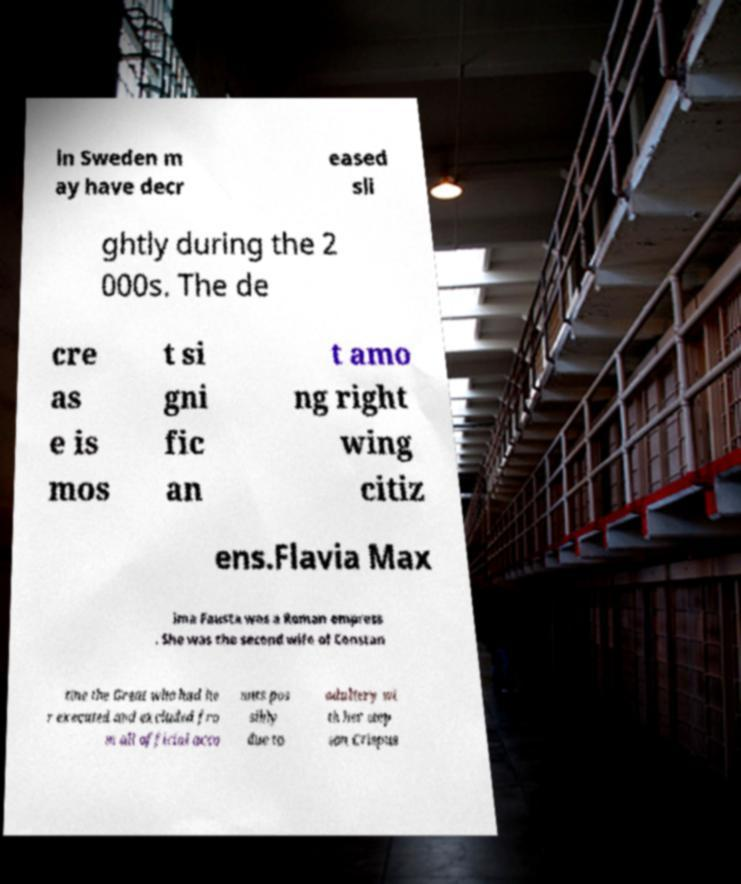Please read and relay the text visible in this image. What does it say? in Sweden m ay have decr eased sli ghtly during the 2 000s. The de cre as e is mos t si gni fic an t amo ng right wing citiz ens.Flavia Max ima Fausta was a Roman empress . She was the second wife of Constan tine the Great who had he r executed and excluded fro m all official acco unts pos sibly due to adultery wi th her step son Crispus 